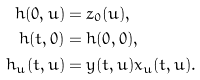Convert formula to latex. <formula><loc_0><loc_0><loc_500><loc_500>h ( 0 , u ) & = z _ { 0 } ( u ) , \\ h ( t , 0 ) & = h ( 0 , 0 ) , \\ h _ { u } ( t , u ) & = y ( t , u ) x _ { u } ( t , u ) .</formula> 